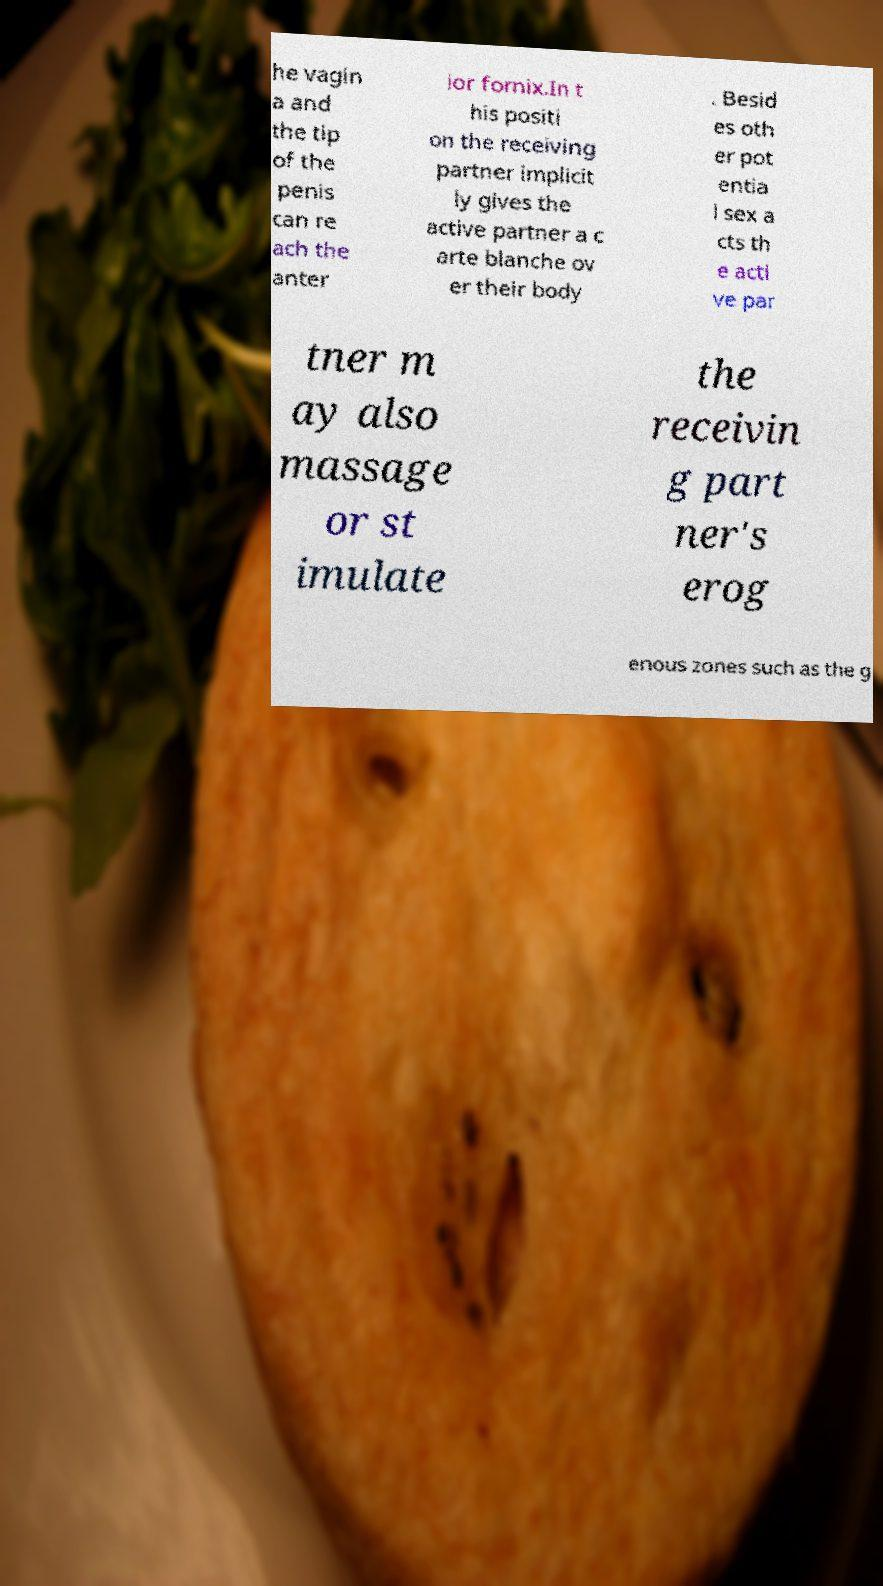Please identify and transcribe the text found in this image. he vagin a and the tip of the penis can re ach the anter ior fornix.In t his positi on the receiving partner implicit ly gives the active partner a c arte blanche ov er their body . Besid es oth er pot entia l sex a cts th e acti ve par tner m ay also massage or st imulate the receivin g part ner's erog enous zones such as the g 